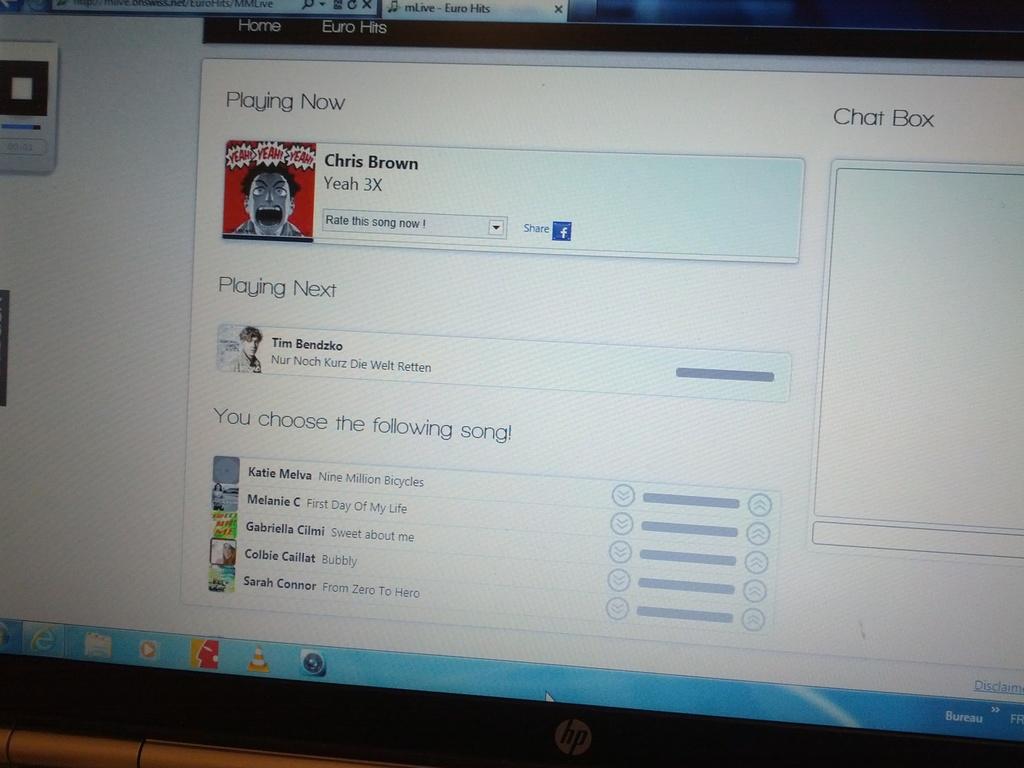What artist is playing now?
Give a very brief answer. Chris brown. What is the song title playing now?
Provide a short and direct response. Yeah 3x. 